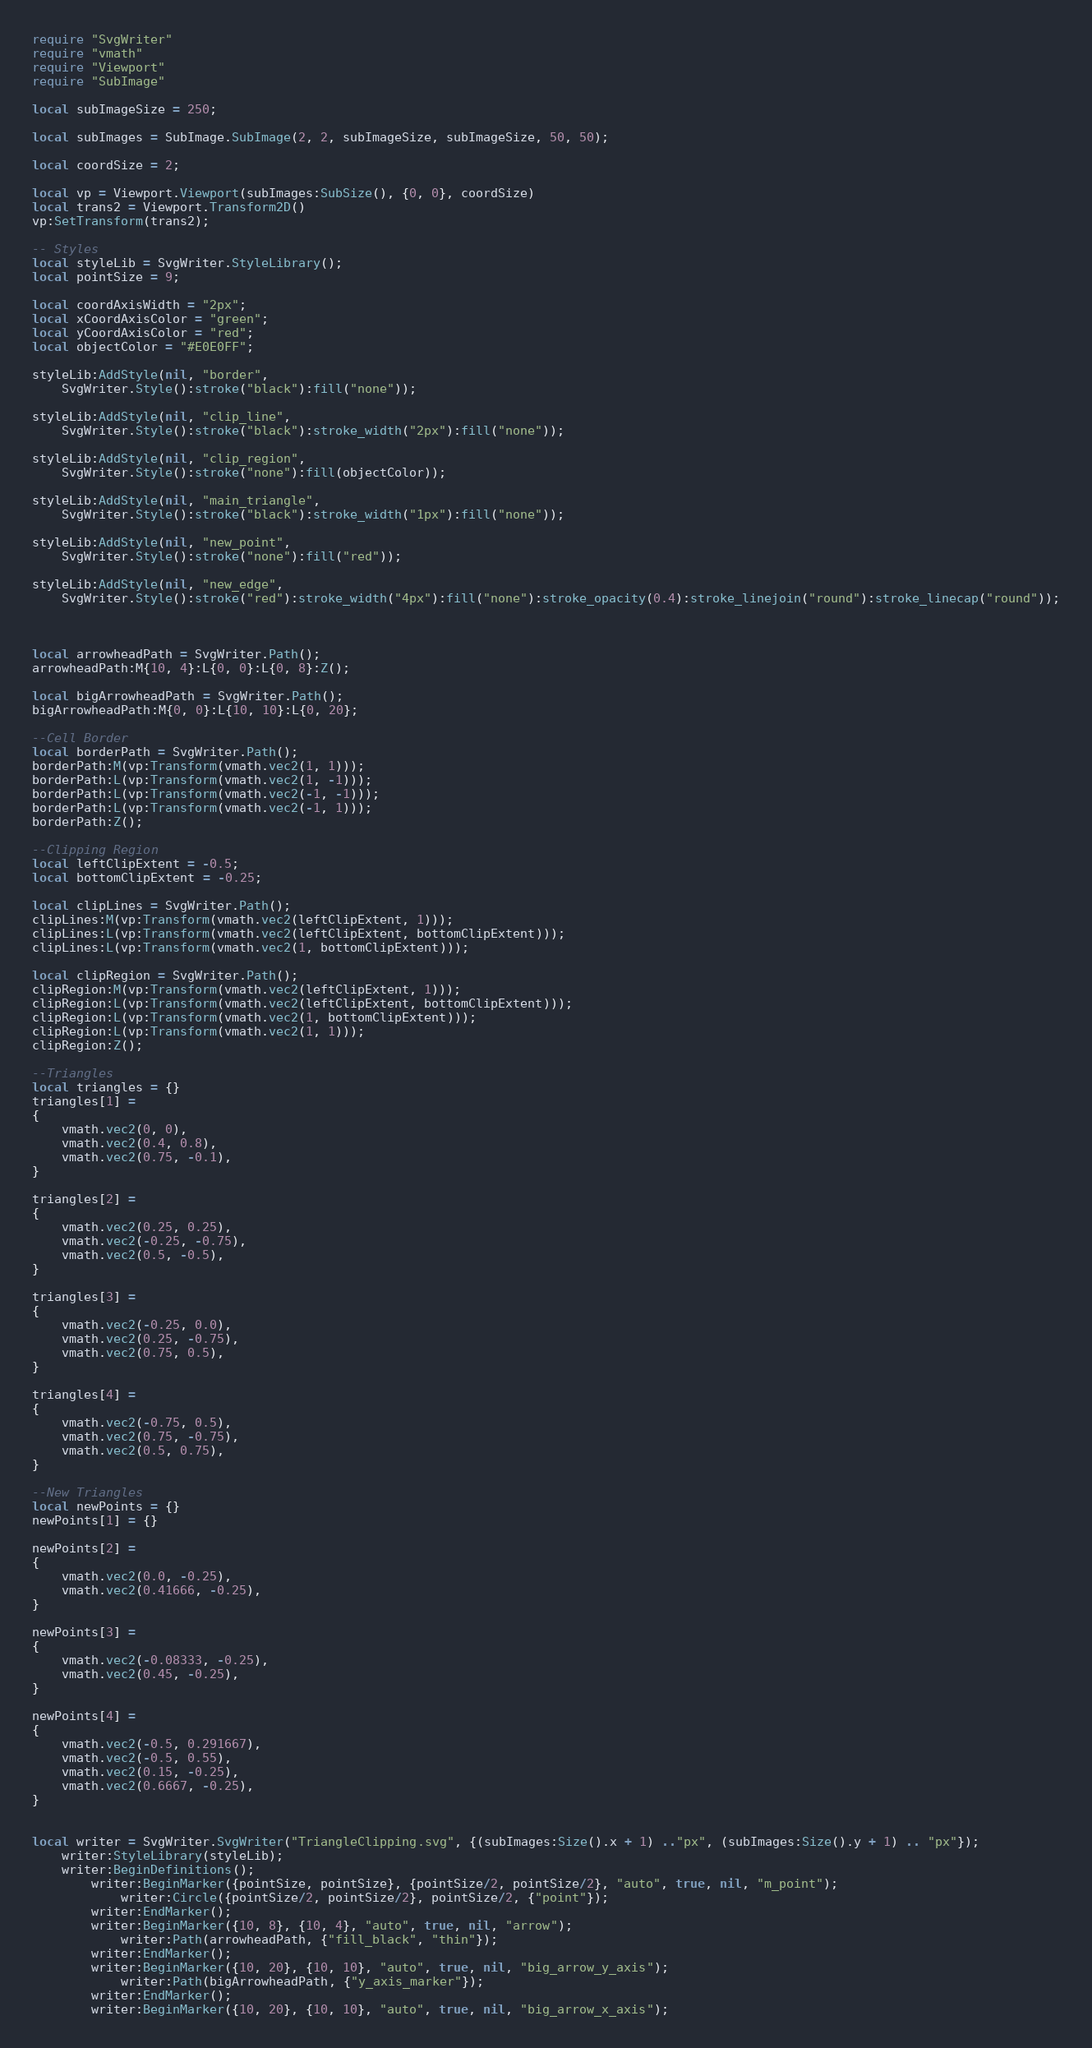<code> <loc_0><loc_0><loc_500><loc_500><_Lua_>require "SvgWriter"
require "vmath"
require "Viewport"
require "SubImage"

local subImageSize = 250;

local subImages = SubImage.SubImage(2, 2, subImageSize, subImageSize, 50, 50);

local coordSize = 2;

local vp = Viewport.Viewport(subImages:SubSize(), {0, 0}, coordSize)
local trans2 = Viewport.Transform2D()
vp:SetTransform(trans2);

-- Styles
local styleLib = SvgWriter.StyleLibrary();
local pointSize = 9;

local coordAxisWidth = "2px";
local xCoordAxisColor = "green";
local yCoordAxisColor = "red";
local objectColor = "#E0E0FF";

styleLib:AddStyle(nil, "border",
	SvgWriter.Style():stroke("black"):fill("none"));
	
styleLib:AddStyle(nil, "clip_line",
	SvgWriter.Style():stroke("black"):stroke_width("2px"):fill("none"));
	
styleLib:AddStyle(nil, "clip_region",
	SvgWriter.Style():stroke("none"):fill(objectColor));
	
styleLib:AddStyle(nil, "main_triangle",
	SvgWriter.Style():stroke("black"):stroke_width("1px"):fill("none"));
	
styleLib:AddStyle(nil, "new_point",
	SvgWriter.Style():stroke("none"):fill("red"));
	
styleLib:AddStyle(nil, "new_edge",
	SvgWriter.Style():stroke("red"):stroke_width("4px"):fill("none"):stroke_opacity(0.4):stroke_linejoin("round"):stroke_linecap("round"));
	
	

local arrowheadPath = SvgWriter.Path();
arrowheadPath:M{10, 4}:L{0, 0}:L{0, 8}:Z();

local bigArrowheadPath = SvgWriter.Path();
bigArrowheadPath:M{0, 0}:L{10, 10}:L{0, 20};

--Cell Border
local borderPath = SvgWriter.Path();
borderPath:M(vp:Transform(vmath.vec2(1, 1)));
borderPath:L(vp:Transform(vmath.vec2(1, -1)));
borderPath:L(vp:Transform(vmath.vec2(-1, -1)));
borderPath:L(vp:Transform(vmath.vec2(-1, 1)));
borderPath:Z();

--Clipping Region
local leftClipExtent = -0.5;
local bottomClipExtent = -0.25;

local clipLines = SvgWriter.Path();
clipLines:M(vp:Transform(vmath.vec2(leftClipExtent, 1)));
clipLines:L(vp:Transform(vmath.vec2(leftClipExtent, bottomClipExtent)));
clipLines:L(vp:Transform(vmath.vec2(1, bottomClipExtent)));

local clipRegion = SvgWriter.Path();
clipRegion:M(vp:Transform(vmath.vec2(leftClipExtent, 1)));
clipRegion:L(vp:Transform(vmath.vec2(leftClipExtent, bottomClipExtent)));
clipRegion:L(vp:Transform(vmath.vec2(1, bottomClipExtent)));
clipRegion:L(vp:Transform(vmath.vec2(1, 1)));
clipRegion:Z();

--Triangles
local triangles = {}
triangles[1] =
{
	vmath.vec2(0, 0),
	vmath.vec2(0.4, 0.8),
	vmath.vec2(0.75, -0.1),
}

triangles[2] =
{
	vmath.vec2(0.25, 0.25),
	vmath.vec2(-0.25, -0.75),
	vmath.vec2(0.5, -0.5),
}

triangles[3] =
{
	vmath.vec2(-0.25, 0.0),
	vmath.vec2(0.25, -0.75),
	vmath.vec2(0.75, 0.5),
}

triangles[4] =
{
	vmath.vec2(-0.75, 0.5),
	vmath.vec2(0.75, -0.75),
	vmath.vec2(0.5, 0.75),
}

--New Triangles
local newPoints = {}
newPoints[1] = {}

newPoints[2] =
{
	vmath.vec2(0.0, -0.25),
	vmath.vec2(0.41666, -0.25),
}

newPoints[3] =
{
	vmath.vec2(-0.08333, -0.25),
	vmath.vec2(0.45, -0.25),
}

newPoints[4] =
{
	vmath.vec2(-0.5, 0.291667),
	vmath.vec2(-0.5, 0.55),
	vmath.vec2(0.15, -0.25),
	vmath.vec2(0.6667, -0.25),
}


local writer = SvgWriter.SvgWriter("TriangleClipping.svg", {(subImages:Size().x + 1) .."px", (subImages:Size().y + 1) .. "px"});
	writer:StyleLibrary(styleLib);
	writer:BeginDefinitions();
		writer:BeginMarker({pointSize, pointSize}, {pointSize/2, pointSize/2}, "auto", true, nil, "m_point");
			writer:Circle({pointSize/2, pointSize/2}, pointSize/2, {"point"});
		writer:EndMarker();
		writer:BeginMarker({10, 8}, {10, 4}, "auto", true, nil, "arrow");
			writer:Path(arrowheadPath, {"fill_black", "thin"});
		writer:EndMarker();
		writer:BeginMarker({10, 20}, {10, 10}, "auto", true, nil, "big_arrow_y_axis");
			writer:Path(bigArrowheadPath, {"y_axis_marker"});
		writer:EndMarker();
		writer:BeginMarker({10, 20}, {10, 10}, "auto", true, nil, "big_arrow_x_axis");</code> 